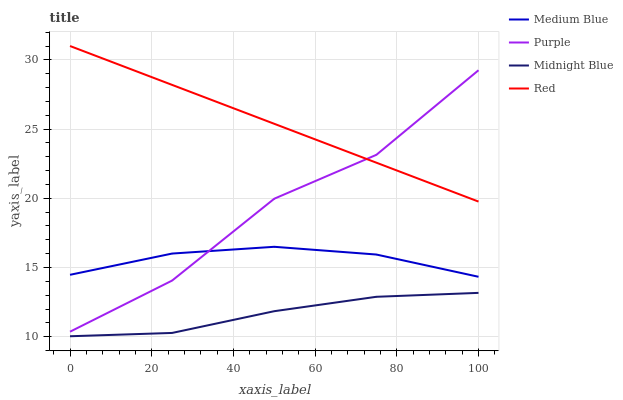Does Midnight Blue have the minimum area under the curve?
Answer yes or no. Yes. Does Red have the maximum area under the curve?
Answer yes or no. Yes. Does Medium Blue have the minimum area under the curve?
Answer yes or no. No. Does Medium Blue have the maximum area under the curve?
Answer yes or no. No. Is Red the smoothest?
Answer yes or no. Yes. Is Purple the roughest?
Answer yes or no. Yes. Is Medium Blue the smoothest?
Answer yes or no. No. Is Medium Blue the roughest?
Answer yes or no. No. Does Medium Blue have the lowest value?
Answer yes or no. No. Does Medium Blue have the highest value?
Answer yes or no. No. Is Midnight Blue less than Purple?
Answer yes or no. Yes. Is Red greater than Midnight Blue?
Answer yes or no. Yes. Does Midnight Blue intersect Purple?
Answer yes or no. No. 